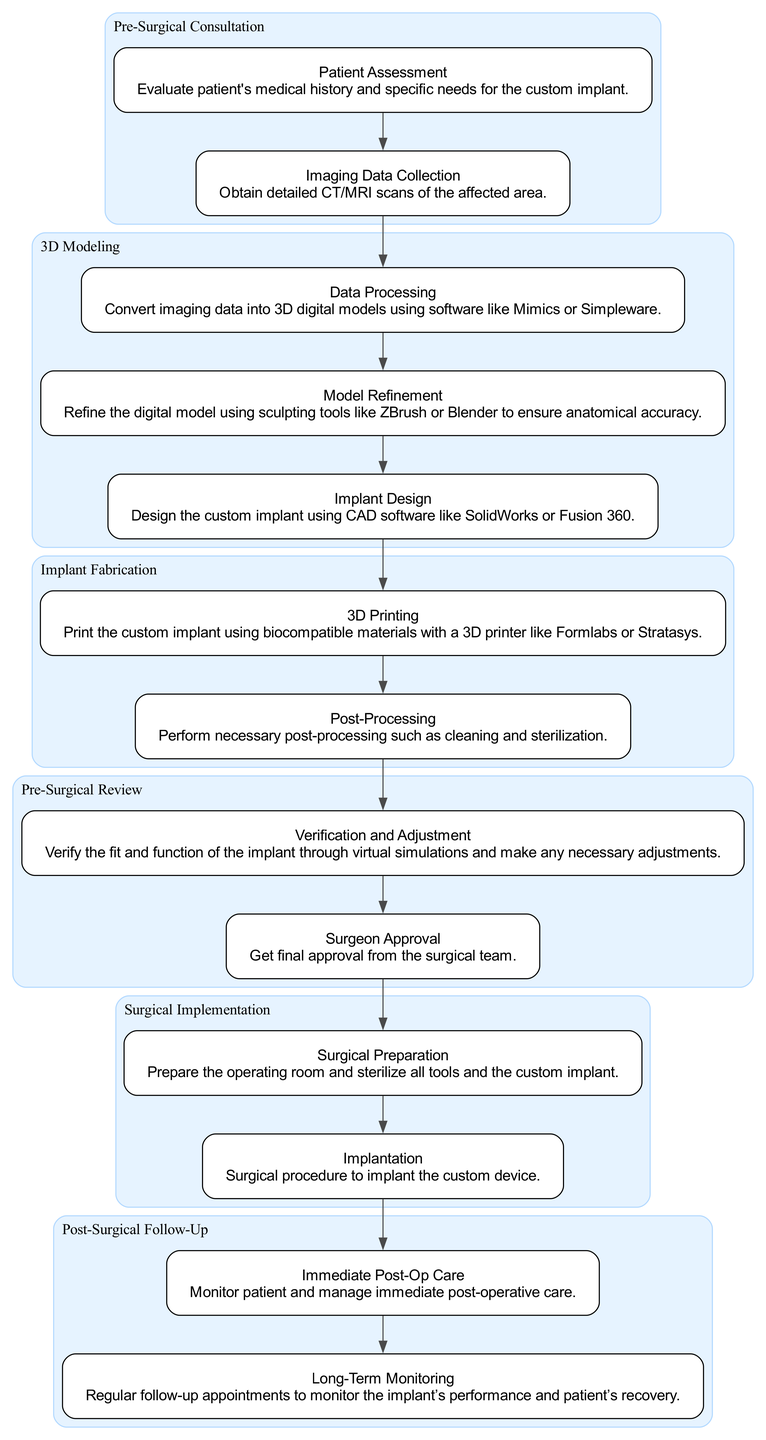What is the first step in the Pre-Surgical Consultation phase? The first step is "Patient Assessment," which involves evaluating the patient's medical history and specific needs for the custom implant. This information is found in the description of the first step under the "Pre-Surgical Consultation" phase.
Answer: Patient Assessment How many steps are in the 3D Modeling phase? The 3D Modeling phase contains three steps: Data Processing, Model Refinement, and Implant Design. This can be determined by counting the steps listed under the corresponding phase in the diagram.
Answer: 3 Which phase follows Implant Fabrication? The phase that follows Implant Fabrication is "Pre-Surgical Review." This is identified by examining the flow of the diagram and noting the order of the phases.
Answer: Pre-Surgical Review What is the last step in the Surgical Implementation phase? The last step in the Surgical Implementation phase is "Implantation," describing the surgical procedure to implant the custom device. This is indicated as the final step in the listing of that phase.
Answer: Implantation Which two steps are involved in Post-Surgical Follow-Up? The two steps are "Immediate Post-Op Care" and "Long-Term Monitoring." This can be confirmed by reviewing the steps outlined in the Post-Surgical Follow-Up phase of the diagram.
Answer: Immediate Post-Op Care, Long-Term Monitoring What is the relationship between the "Implant Design" step and the "Verification and Adjustment" step? "Implant Design" is the last step in the 3D Modeling phase, and "Verification and Adjustment" is the first step in the Pre-Surgical Review phase. These steps are connected through the flow of the diagram where the end of one phase leads into the start of the next.
Answer: Sequential How many total phases are depicted in the diagram? There are six phases depicted in the diagram, which can be counted directly from the list of phases presented in the clinical pathway.
Answer: 6 What is the primary outcome of the "Data Processing" step? The primary outcome of the "Data Processing" step is the conversion of imaging data into 3D digital models. This information is provided in the description of the step within the 3D Modeling phase.
Answer: 3D digital models What role does "Surgeon Approval" play in the clinical pathway? "Surgeon Approval" is critical as it represents the final step in the Pre-Surgical Review phase, ensuring the surgical team approves the custom implant before proceeding. This step is essential for confirming readiness for surgery and is indicated as the last step in its phase.
Answer: Final approval 